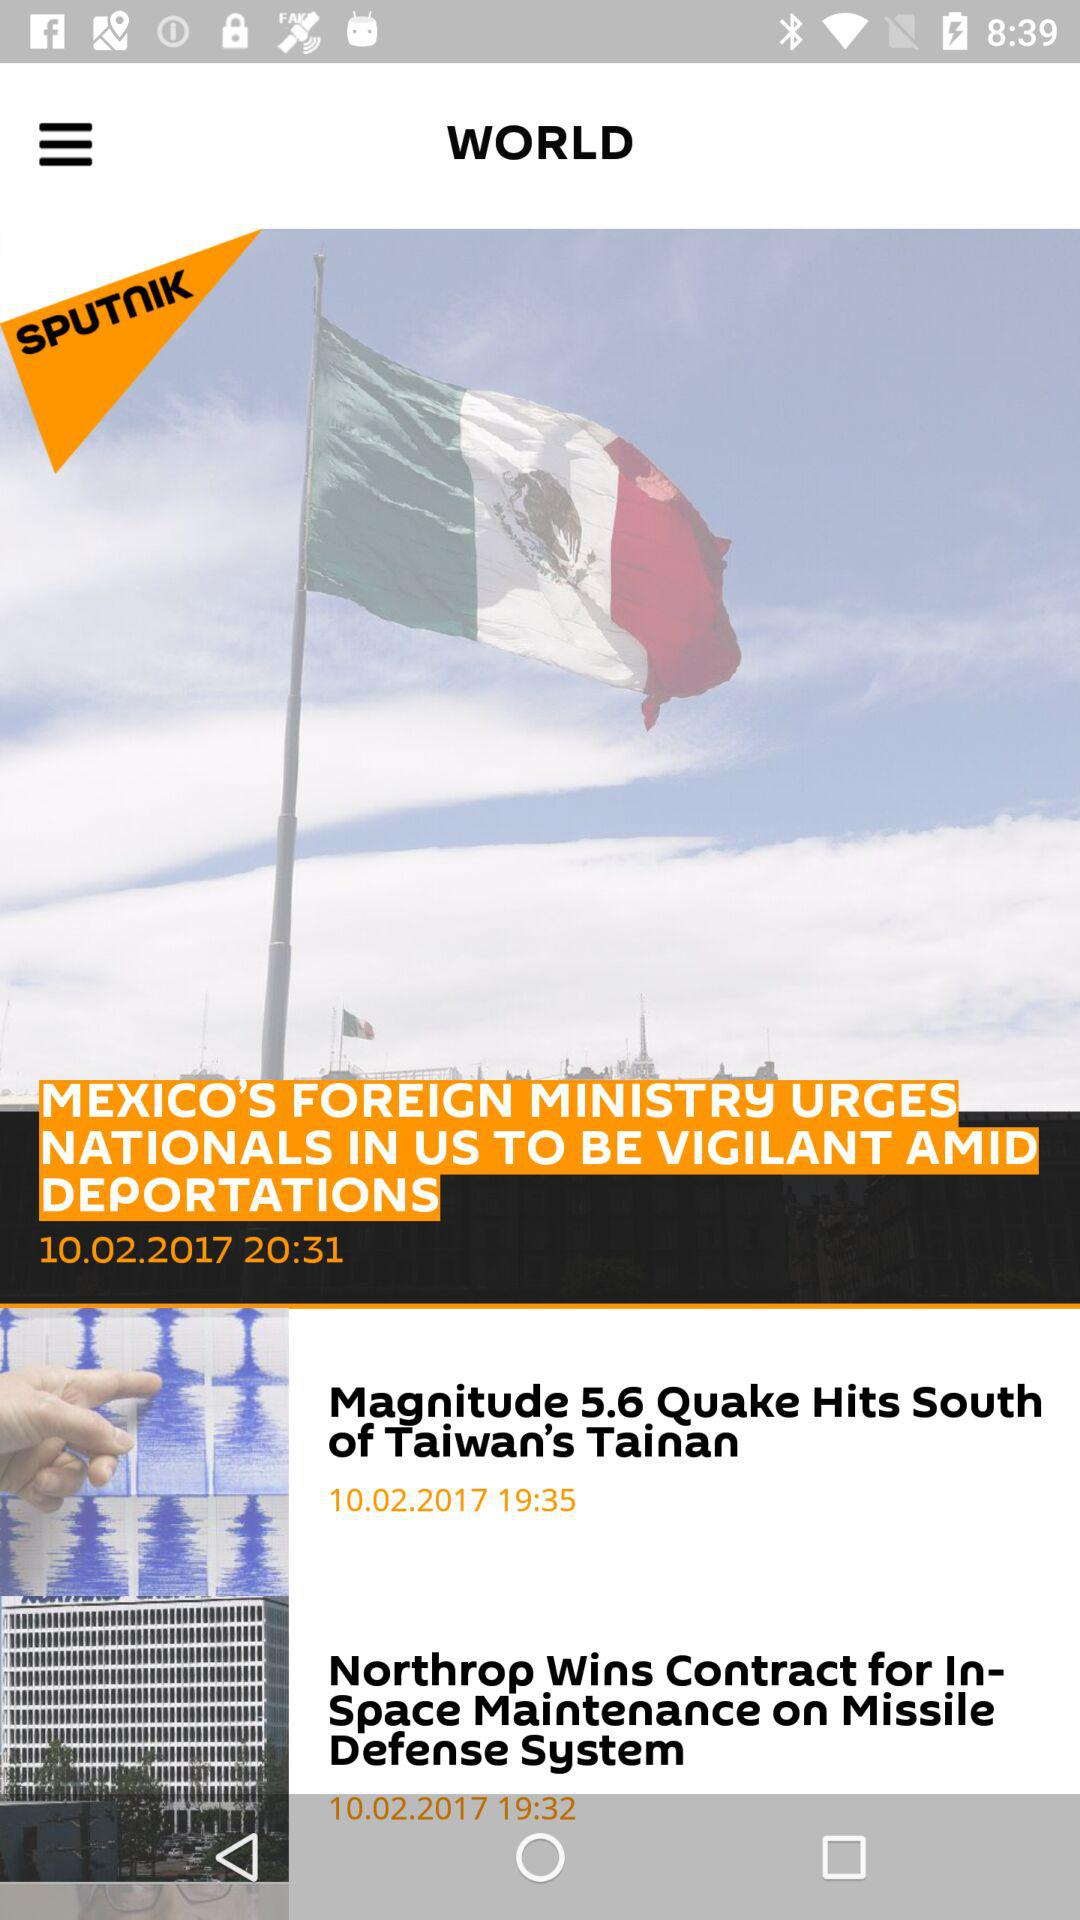What is the publication date of the article "Magnitude 5.6 Quake Hits South of Taiwan's Tainan"? The publication date is 10.02.2017. 